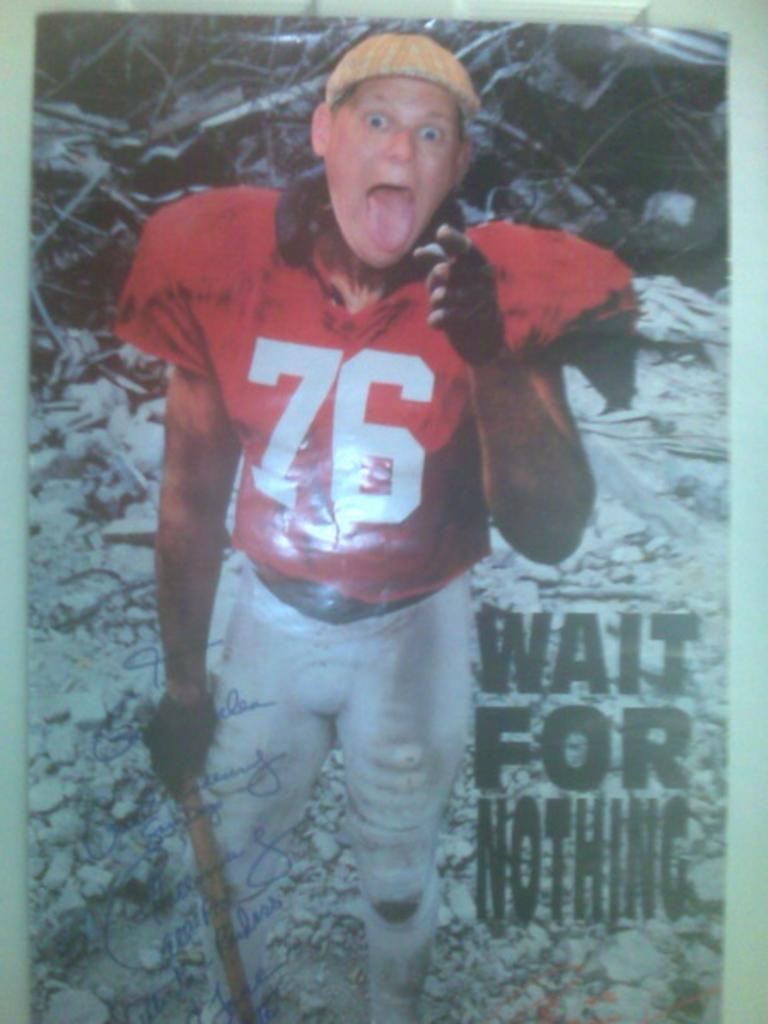Who is present in the image? There is a man in the image. What is the condition of the ground where the man is standing? The man is standing on icy ground. Who or what is the man looking at? The man is looking at someone. What type of credit card is the man holding in the image? There is no credit card visible in the image; the man is simply standing on icy ground and looking at someone. 